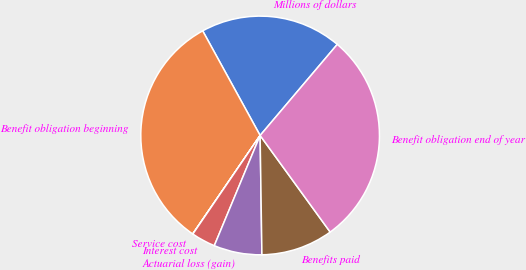Convert chart. <chart><loc_0><loc_0><loc_500><loc_500><pie_chart><fcel>Millions of dollars<fcel>Benefit obligation beginning<fcel>Service cost<fcel>Interest cost<fcel>Actuarial loss (gain)<fcel>Benefits paid<fcel>Benefit obligation end of year<nl><fcel>19.18%<fcel>32.46%<fcel>0.02%<fcel>3.26%<fcel>6.51%<fcel>9.75%<fcel>28.83%<nl></chart> 